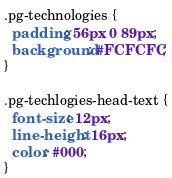Convert code to text. <code><loc_0><loc_0><loc_500><loc_500><_CSS_>.pg-technologies {
  padding: 56px 0 89px;
  background: #FCFCFC;
}

.pg-techlogies-head-text {
  font-size: 12px;
  line-height: 16px;
  color: #000;
}</code> 